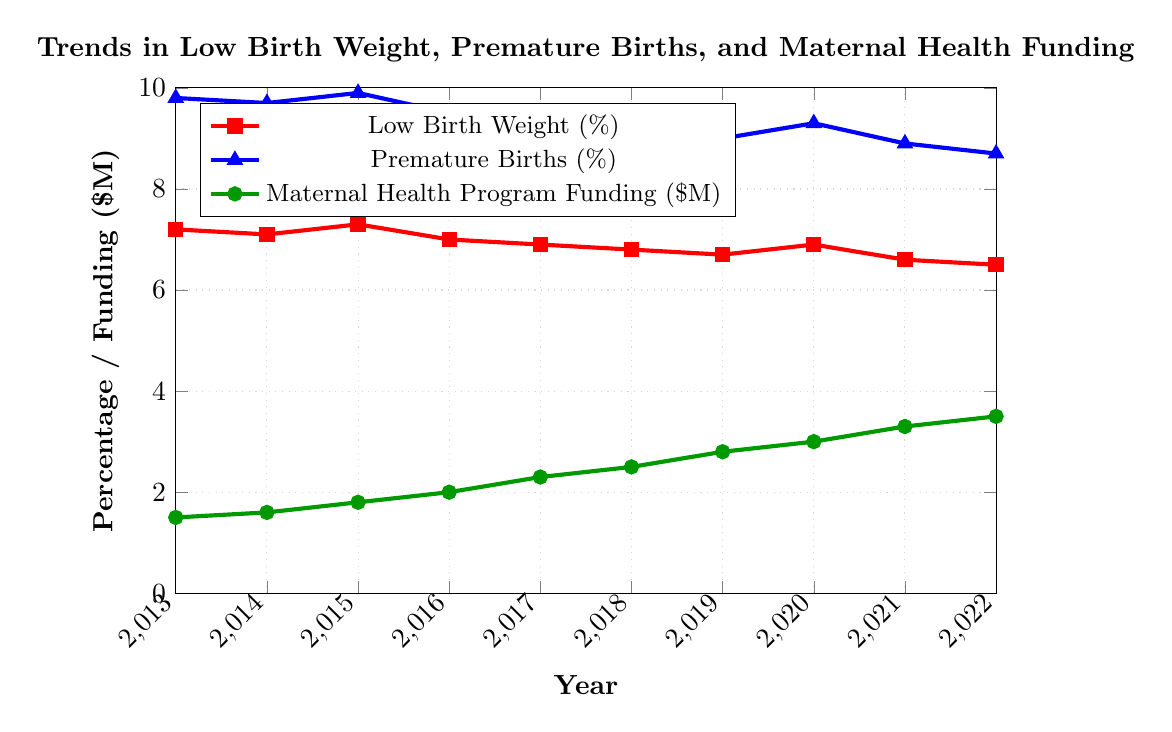What's the trend in low birth weight percentages over the last decade? To determine the trend, observe the red line representing "Low Birth Weight (%)" on the chart from 2013 to 2022. Notice a general downward direction. Although there is a slight increase around 2015 and 2020, the overall trend shows a decrease.
Answer: Decreasing trend When did the maternal health program funding see the most significant increase? To identify the most significant increase in funding, examine the green line representing "Maternal Health Program Funding ($M)". Find the steepest upward slope, which occurs between 2016 and 2017, indicating the funding increased by $0.3 million during this period.
Answer: 2016 to 2017 What is the difference in low birth weight percentages between 2013 and 2022? Look at the low birth weight percentages (red line) in 2013 and 2022. In 2013, the value is 7.2%, and in 2022, it is 6.5%. Subtract the latter from the former: 7.2% - 6.5% = 0.7%.
Answer: 0.7% In what year did premature births fall below 9% for the first time? Observe the blue line representing "Premature Births (%)". Note the point at which this line first dips below 9%. This occurs in 2019, where the percentage is 9.0%. The following year, 2021, the value is 8.9%.
Answer: 2021 How does the percentage of low birth weight in 2018 compare to that in 2015? Compare the values on the red line for the years 2018 and 2015. In 2015, the percentage is 7.3%, whereas in 2018, it is 6.8%.
Answer: Lower in 2018 What's the average increase in maternal health program funding per year between 2013 and 2022? Determine the initial (2013: $1.5M) and final (2022: $3.5M) funding values. Calculate the total increase: 3.5M - 1.5M = $2M. Since the period is 9 years (2022 - 2013), divide the total increase by 9: $2M / 9 = $0.22M per year.
Answer: $0.22M per year Identify the year with the highest percentage of premature births and specify the percentage. Check the peak value on the blue line. The highest percentage is 9.9% in 2015.
Answer: 2015, 9.9% Compare the trends of low birth weight and premature births over the last decade. Both trends show a general downward direction. For low birth weight (red line), there's a consistent decrease except for slight increases around 2015 and 2020. For premature births (blue line), there's an overall decline with minor fluctuations.
Answer: Both are decreasing What was the percentage change in premature births from 2013 to 2022? Observe the percentages in 2013 (9.8%) and 2022 (8.7%). Calculate the percentage change: ((8.7 - 9.8) / 9.8) * 100% = -11.22%.
Answer: -11.22% Which year had the lowest funding for maternal health programs and what was the amount? The green line indicates the lowest funding is in 2013, with an amount of $1.5M.
Answer: 2013, $1.5M 